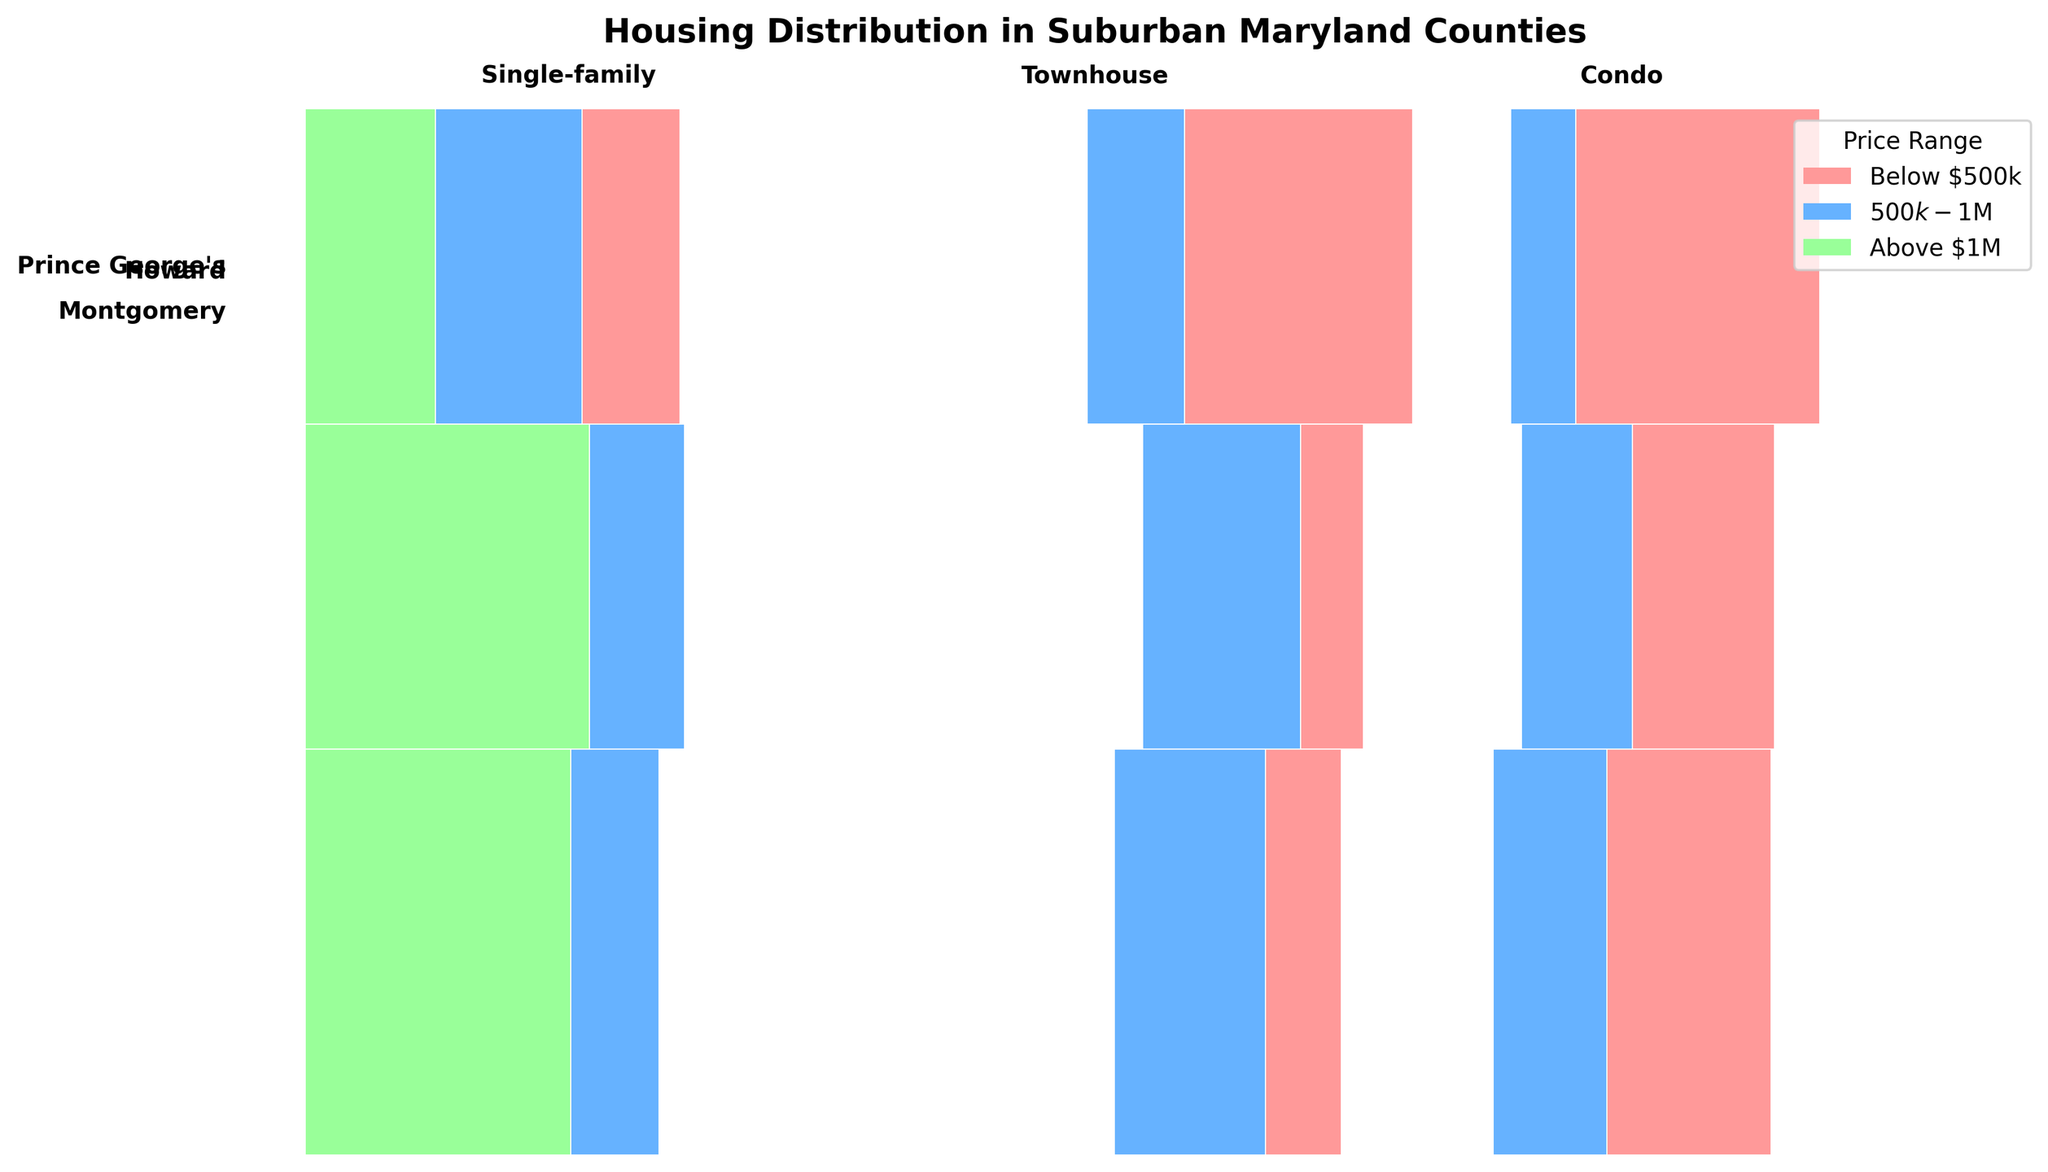What counties are represented in the plot? The plot is divided by the counties Montgomery, Howard, and Prince George's, which are shown along the Y-axis as different segments, each labeled with the respective county names.
Answer: Montgomery, Howard, Prince George's Which housing types are displayed in the plot? The plot includes three housing types that are labeled at the top of the plot. These housing types are Single-family, Townhouse, and Condo.
Answer: Single-family, Townhouse, Condo What colors are used to represent different price ranges in the plot? The plot uses three different colors to represent price ranges: Below $500k is shown in pink, $500k-$1M is shown in light blue, and Above $1M is shown in light green.
Answer: Pink, light blue, light green Which county has the highest proportion of Single-family homes Above $1M? The tallest green section associated with Single-family homes Above $1M can be observed for Montgomery County, indicating that it has the highest proportion in this price range.
Answer: Montgomery Among all three counties, which has the most significant proportion of Condos in the Below $500k price range? The plot shows the widest pink section under Condos for Montgomery County, indicating it has the largest proportion of Condos in the Below $500k price range among the three counties.
Answer: Montgomery Is there a price range where Townhouses are more popular in Prince George's County compared to Howard County? When comparing the widths of the sections for Townhouses in Prince George's and Howard Counties, it's evident that Below $500k (shown in pink) has a significantly wider section for Prince George's County, indicating more popularity.
Answer: Below $500k What is the proportion of Condos in the $500k-$1M price range in Howard County compared to Prince George's County? Prince George's County has a smaller light blue section for Condos in the $500k-$1M price range compared to Howard County, signifying a lower proportion in this price range.
Answer: Smaller in Prince George's Which price range is less common for Single-family homes in Prince George's County? In Prince George's County, the smallest proportion of Single-family homes is represented by the green section, indicating that the Above $1M price range is least common.
Answer: Above $1M 